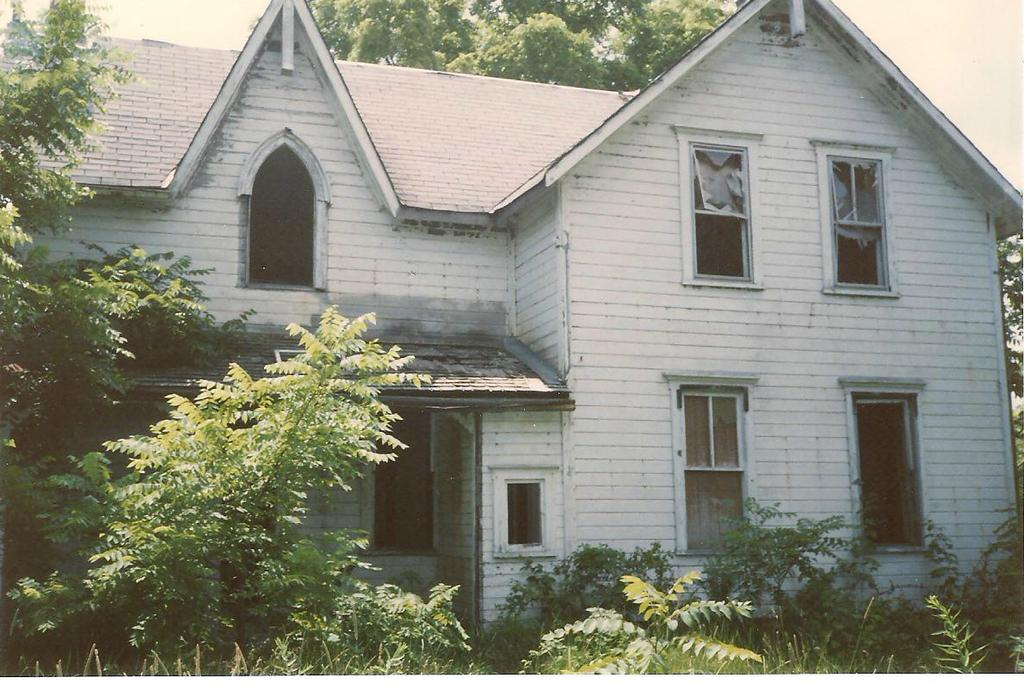What type of vegetation can be seen in the image? There are trees in the image. What type of structure is present in the image? There is a building with windows in the image. Where are the trees located in relation to the building? The trees are at the back of the image. What is visible at the top of the image? The sky is visible at the top of the image. How many girls are visible in the image? There are no girls present in the image. What type of work is being done on the trees in the image? There is no work being done on the trees in the image; they are simply standing. 